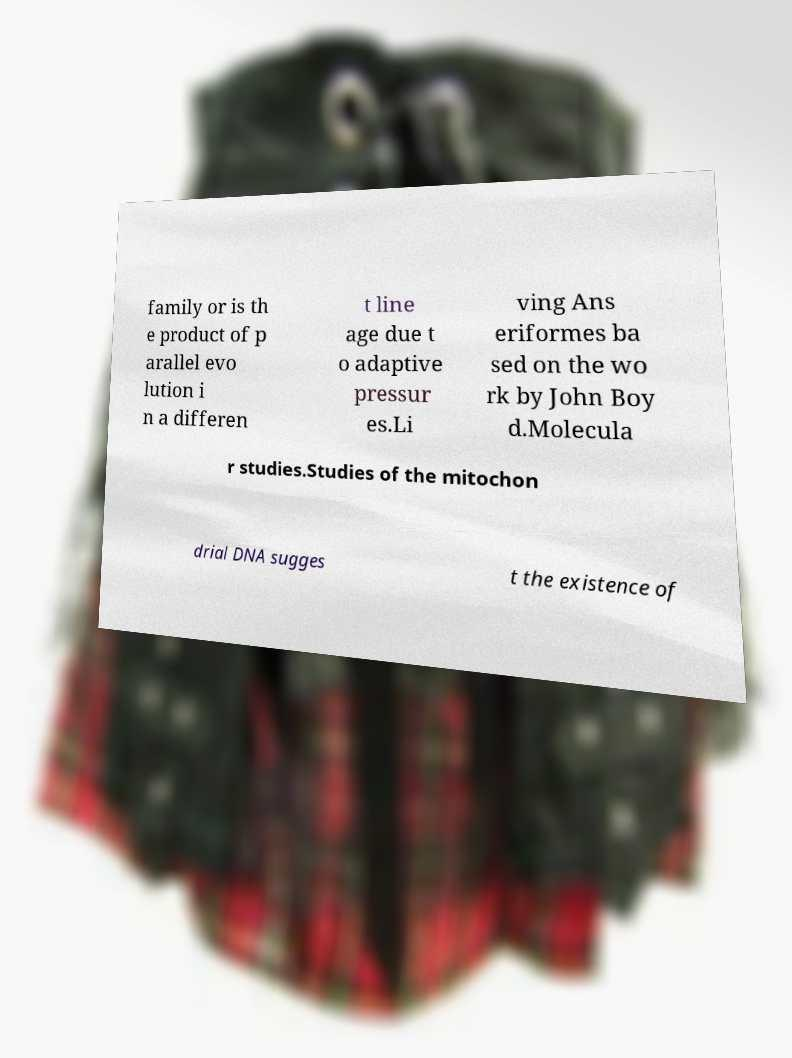What messages or text are displayed in this image? I need them in a readable, typed format. family or is th e product of p arallel evo lution i n a differen t line age due t o adaptive pressur es.Li ving Ans eriformes ba sed on the wo rk by John Boy d.Molecula r studies.Studies of the mitochon drial DNA sugges t the existence of 